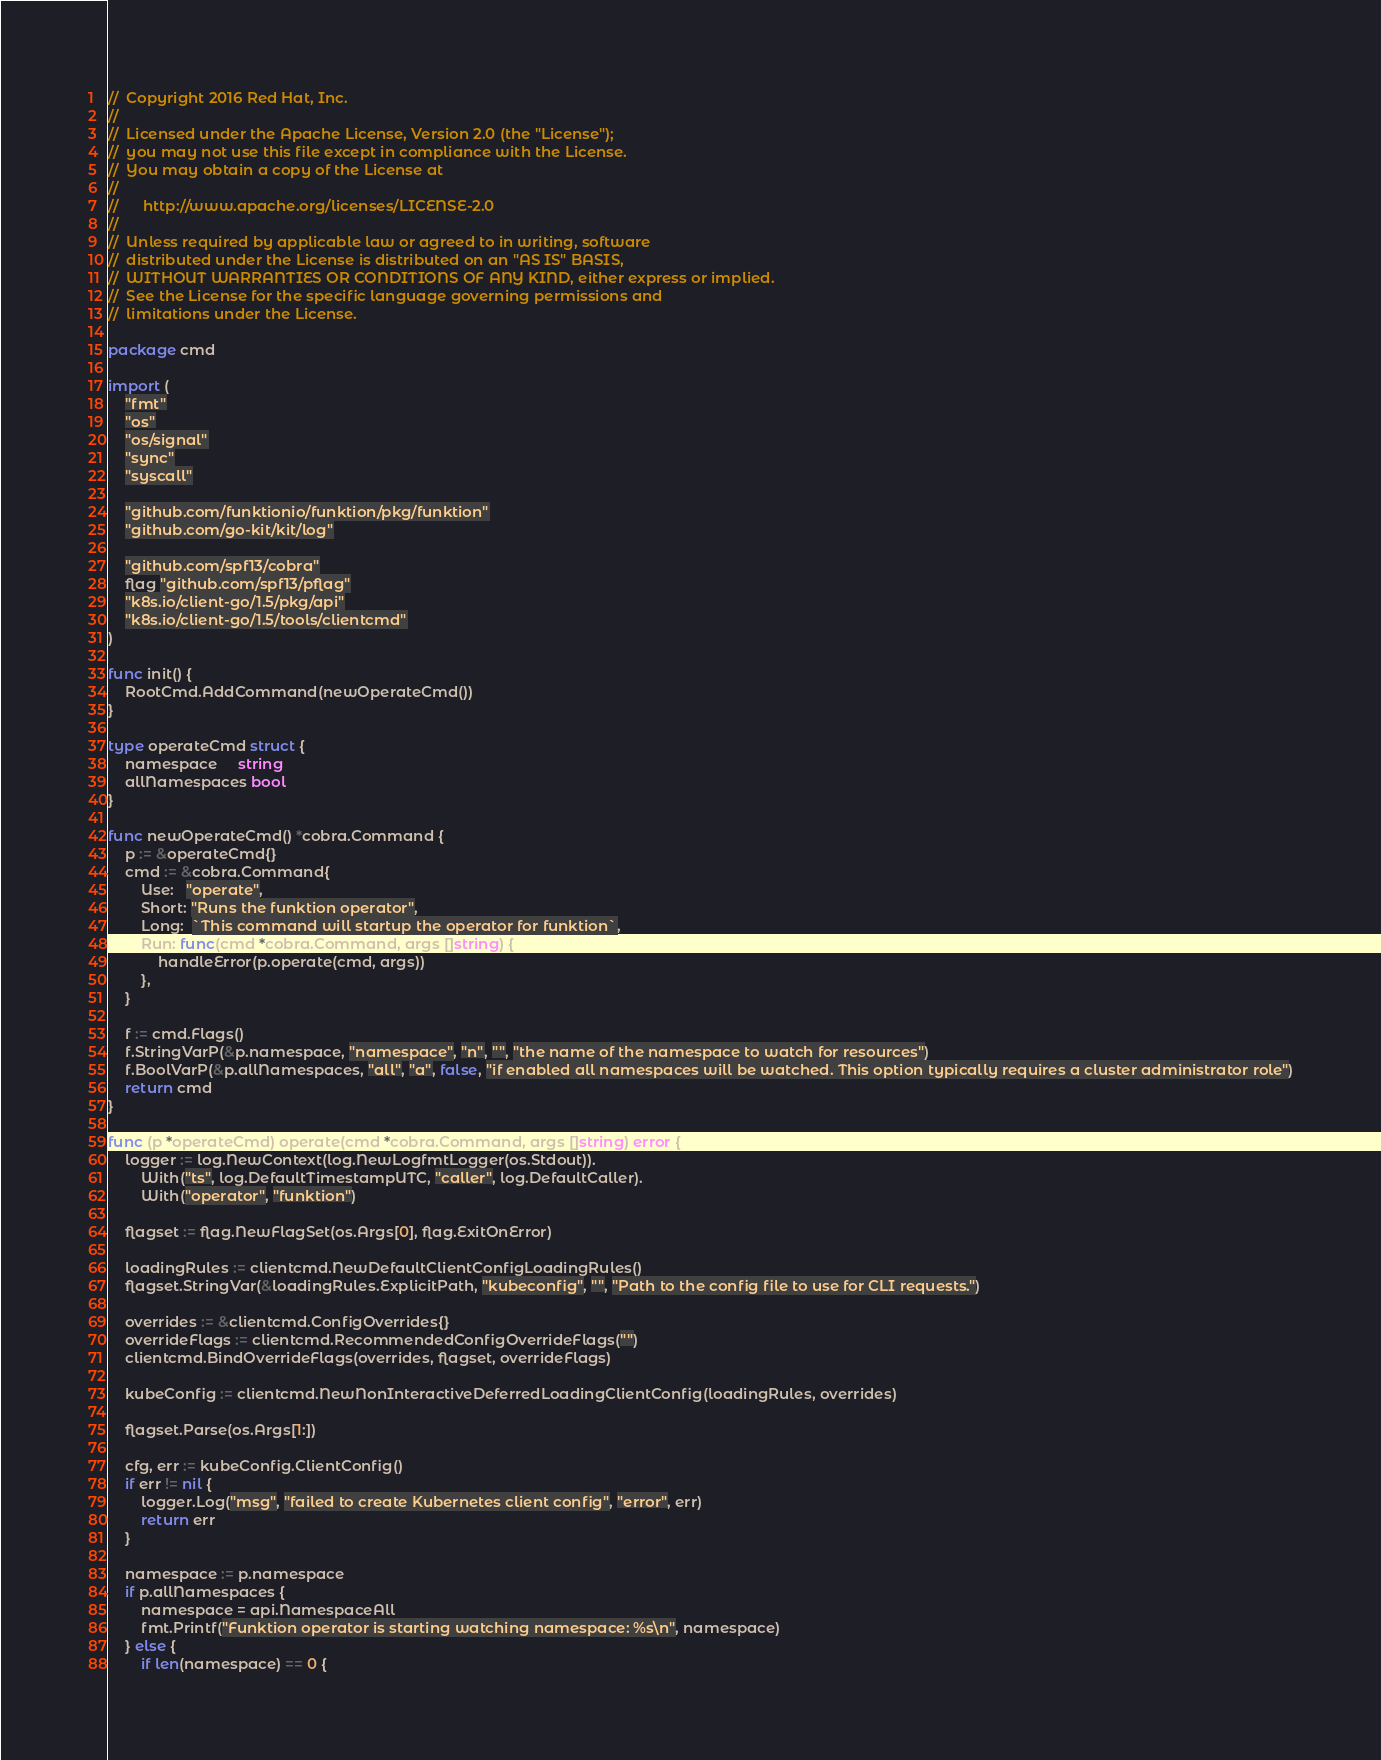<code> <loc_0><loc_0><loc_500><loc_500><_Go_>//  Copyright 2016 Red Hat, Inc.
//
//  Licensed under the Apache License, Version 2.0 (the "License");
//  you may not use this file except in compliance with the License.
//  You may obtain a copy of the License at
//
//      http://www.apache.org/licenses/LICENSE-2.0
//
//  Unless required by applicable law or agreed to in writing, software
//  distributed under the License is distributed on an "AS IS" BASIS,
//  WITHOUT WARRANTIES OR CONDITIONS OF ANY KIND, either express or implied.
//  See the License for the specific language governing permissions and
//  limitations under the License.

package cmd

import (
	"fmt"
	"os"
	"os/signal"
	"sync"
	"syscall"

	"github.com/funktionio/funktion/pkg/funktion"
	"github.com/go-kit/kit/log"

	"github.com/spf13/cobra"
	flag "github.com/spf13/pflag"
	"k8s.io/client-go/1.5/pkg/api"
	"k8s.io/client-go/1.5/tools/clientcmd"
)

func init() {
	RootCmd.AddCommand(newOperateCmd())
}

type operateCmd struct {
	namespace     string
	allNamespaces bool
}

func newOperateCmd() *cobra.Command {
	p := &operateCmd{}
	cmd := &cobra.Command{
		Use:   "operate",
		Short: "Runs the funktion operator",
		Long:  `This command will startup the operator for funktion`,
		Run: func(cmd *cobra.Command, args []string) {
			handleError(p.operate(cmd, args))
		},
	}

	f := cmd.Flags()
	f.StringVarP(&p.namespace, "namespace", "n", "", "the name of the namespace to watch for resources")
	f.BoolVarP(&p.allNamespaces, "all", "a", false, "if enabled all namespaces will be watched. This option typically requires a cluster administrator role")
	return cmd
}

func (p *operateCmd) operate(cmd *cobra.Command, args []string) error {
	logger := log.NewContext(log.NewLogfmtLogger(os.Stdout)).
		With("ts", log.DefaultTimestampUTC, "caller", log.DefaultCaller).
		With("operator", "funktion")

	flagset := flag.NewFlagSet(os.Args[0], flag.ExitOnError)

	loadingRules := clientcmd.NewDefaultClientConfigLoadingRules()
	flagset.StringVar(&loadingRules.ExplicitPath, "kubeconfig", "", "Path to the config file to use for CLI requests.")

	overrides := &clientcmd.ConfigOverrides{}
	overrideFlags := clientcmd.RecommendedConfigOverrideFlags("")
	clientcmd.BindOverrideFlags(overrides, flagset, overrideFlags)

	kubeConfig := clientcmd.NewNonInteractiveDeferredLoadingClientConfig(loadingRules, overrides)

	flagset.Parse(os.Args[1:])

	cfg, err := kubeConfig.ClientConfig()
	if err != nil {
		logger.Log("msg", "failed to create Kubernetes client config", "error", err)
		return err
	}

	namespace := p.namespace
	if p.allNamespaces {
		namespace = api.NamespaceAll
		fmt.Printf("Funktion operator is starting watching namespace: %s\n", namespace)
	} else {
		if len(namespace) == 0 {</code> 